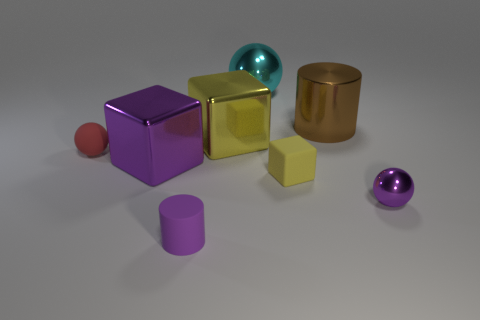There is a metallic cube left of the small purple rubber thing; what is its color? purple 